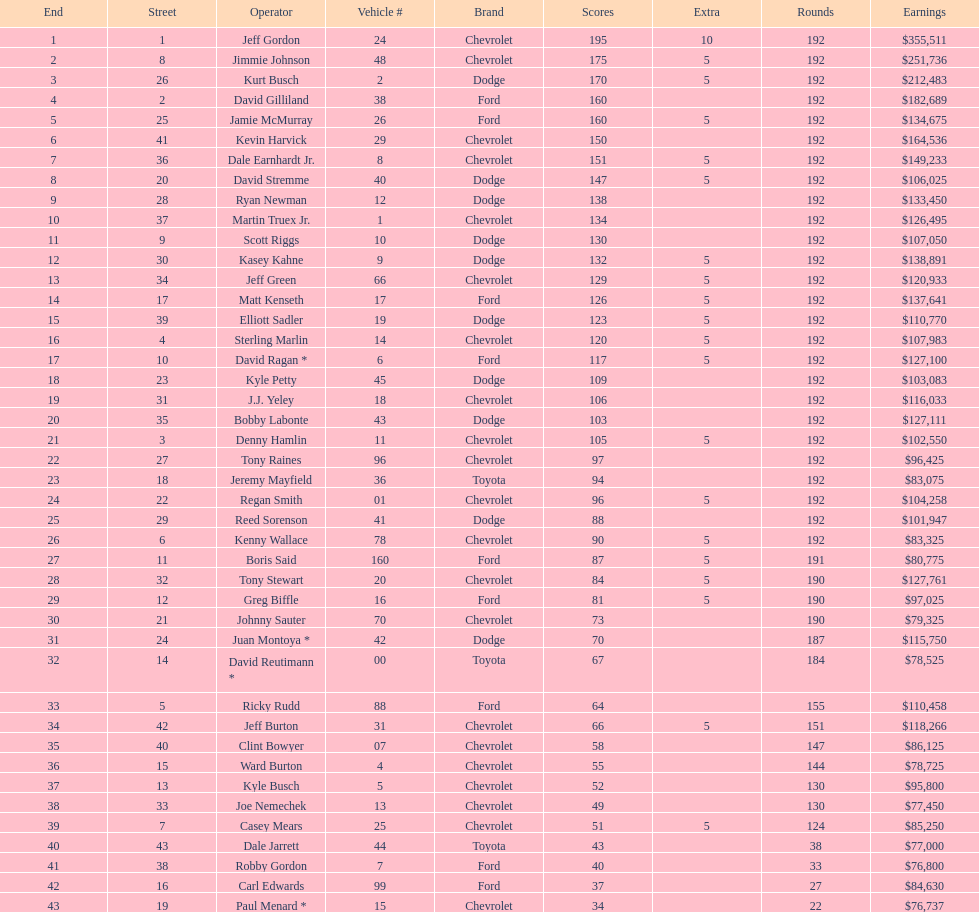What was the make of both jeff gordon's and jimmie johnson's race car? Chevrolet. 